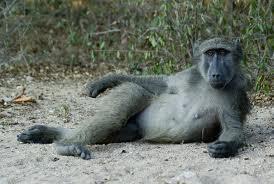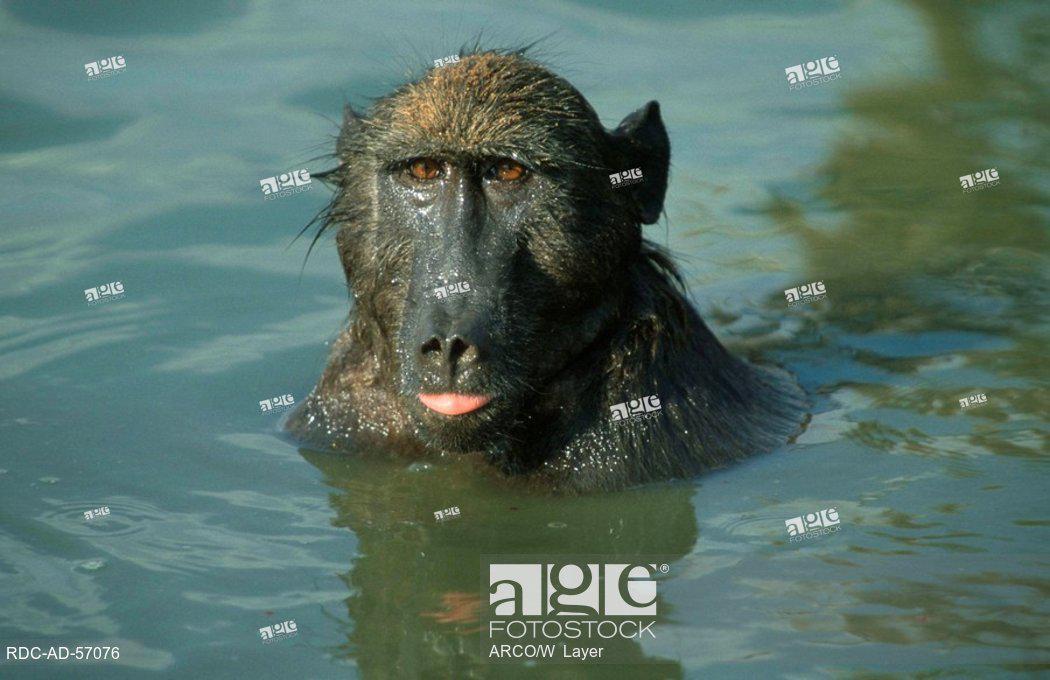The first image is the image on the left, the second image is the image on the right. For the images shown, is this caption "The left image includes at least one baboon perched on a cement ledge next to water, and the right image includes at least one baboon neck-deep in water." true? Answer yes or no. No. 